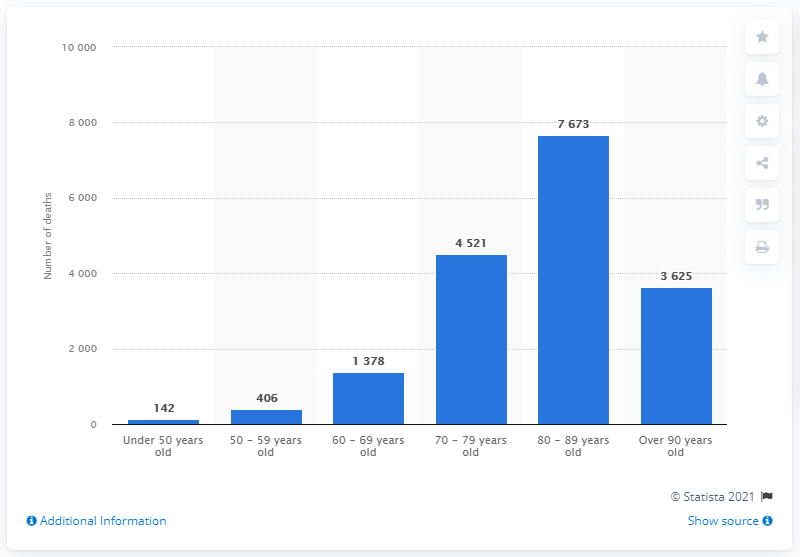List a handful of essential elements in this visual. The difference between the highest and lowest age groups is 7531. In patients aged between 80 and 89 years, a total of 7,673 deaths were recorded. According to data from the Netherlands, the age group with the highest number of deaths is individuals aged 80 to 89. 